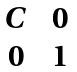<formula> <loc_0><loc_0><loc_500><loc_500>\begin{matrix} C \ & 0 \\ 0 \ & 1 \end{matrix}</formula> 